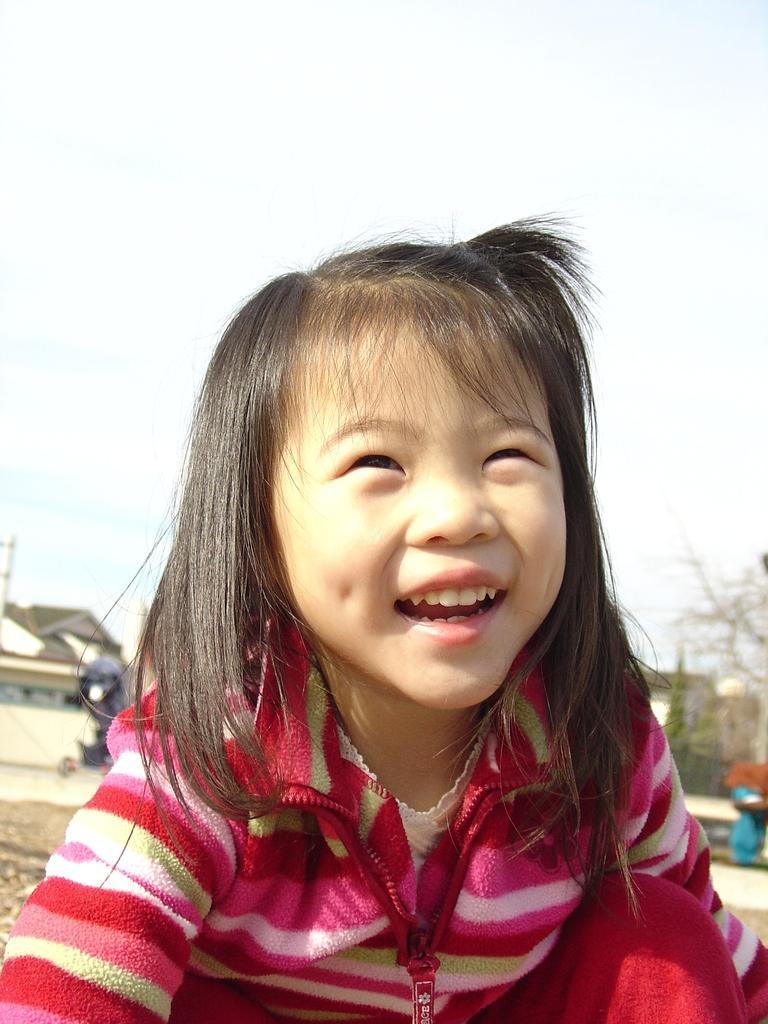How would you summarize this image in a sentence or two? We can see a girl with a smile and she has black hair and wearing a red color jacket. On the right side, we can see tree. On the left side, we can see a house and the sky is clear. 